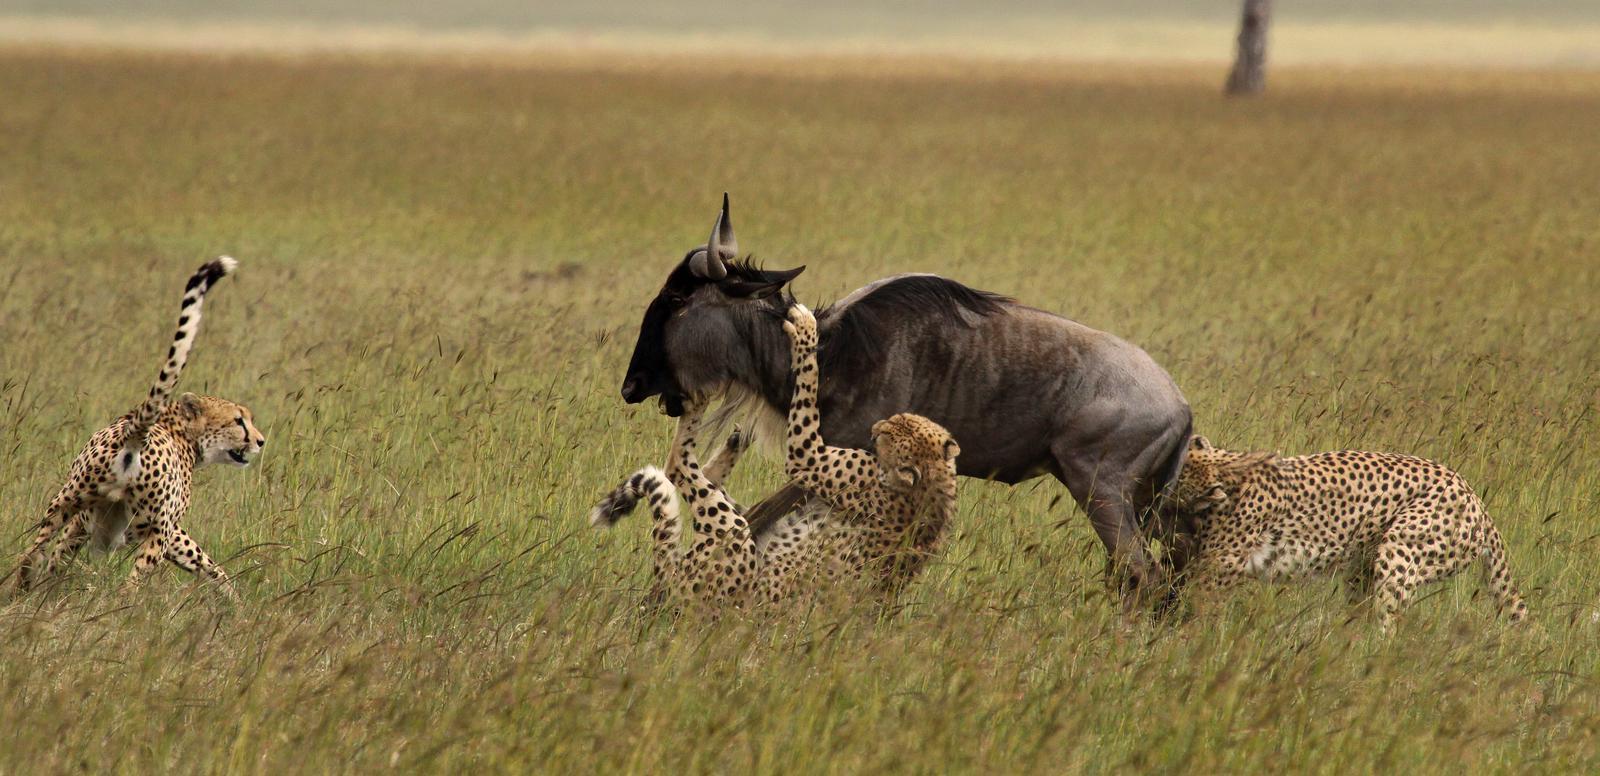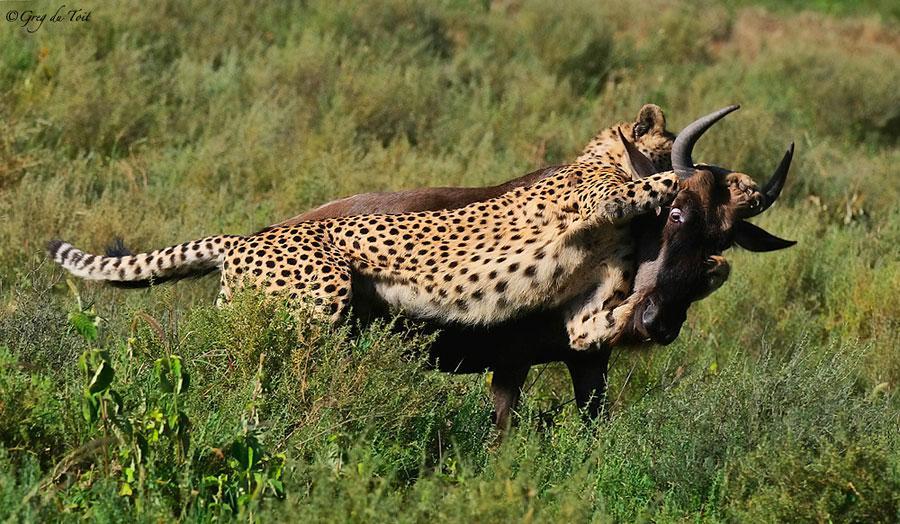The first image is the image on the left, the second image is the image on the right. Assess this claim about the two images: "a wildebeest is being held by two cheetahs". Correct or not? Answer yes or no. Yes. The first image is the image on the left, the second image is the image on the right. Assess this claim about the two images: "An image shows a spotted wildcat standing on its hind legs, with its front paws grasping a horned animal.". Correct or not? Answer yes or no. Yes. 